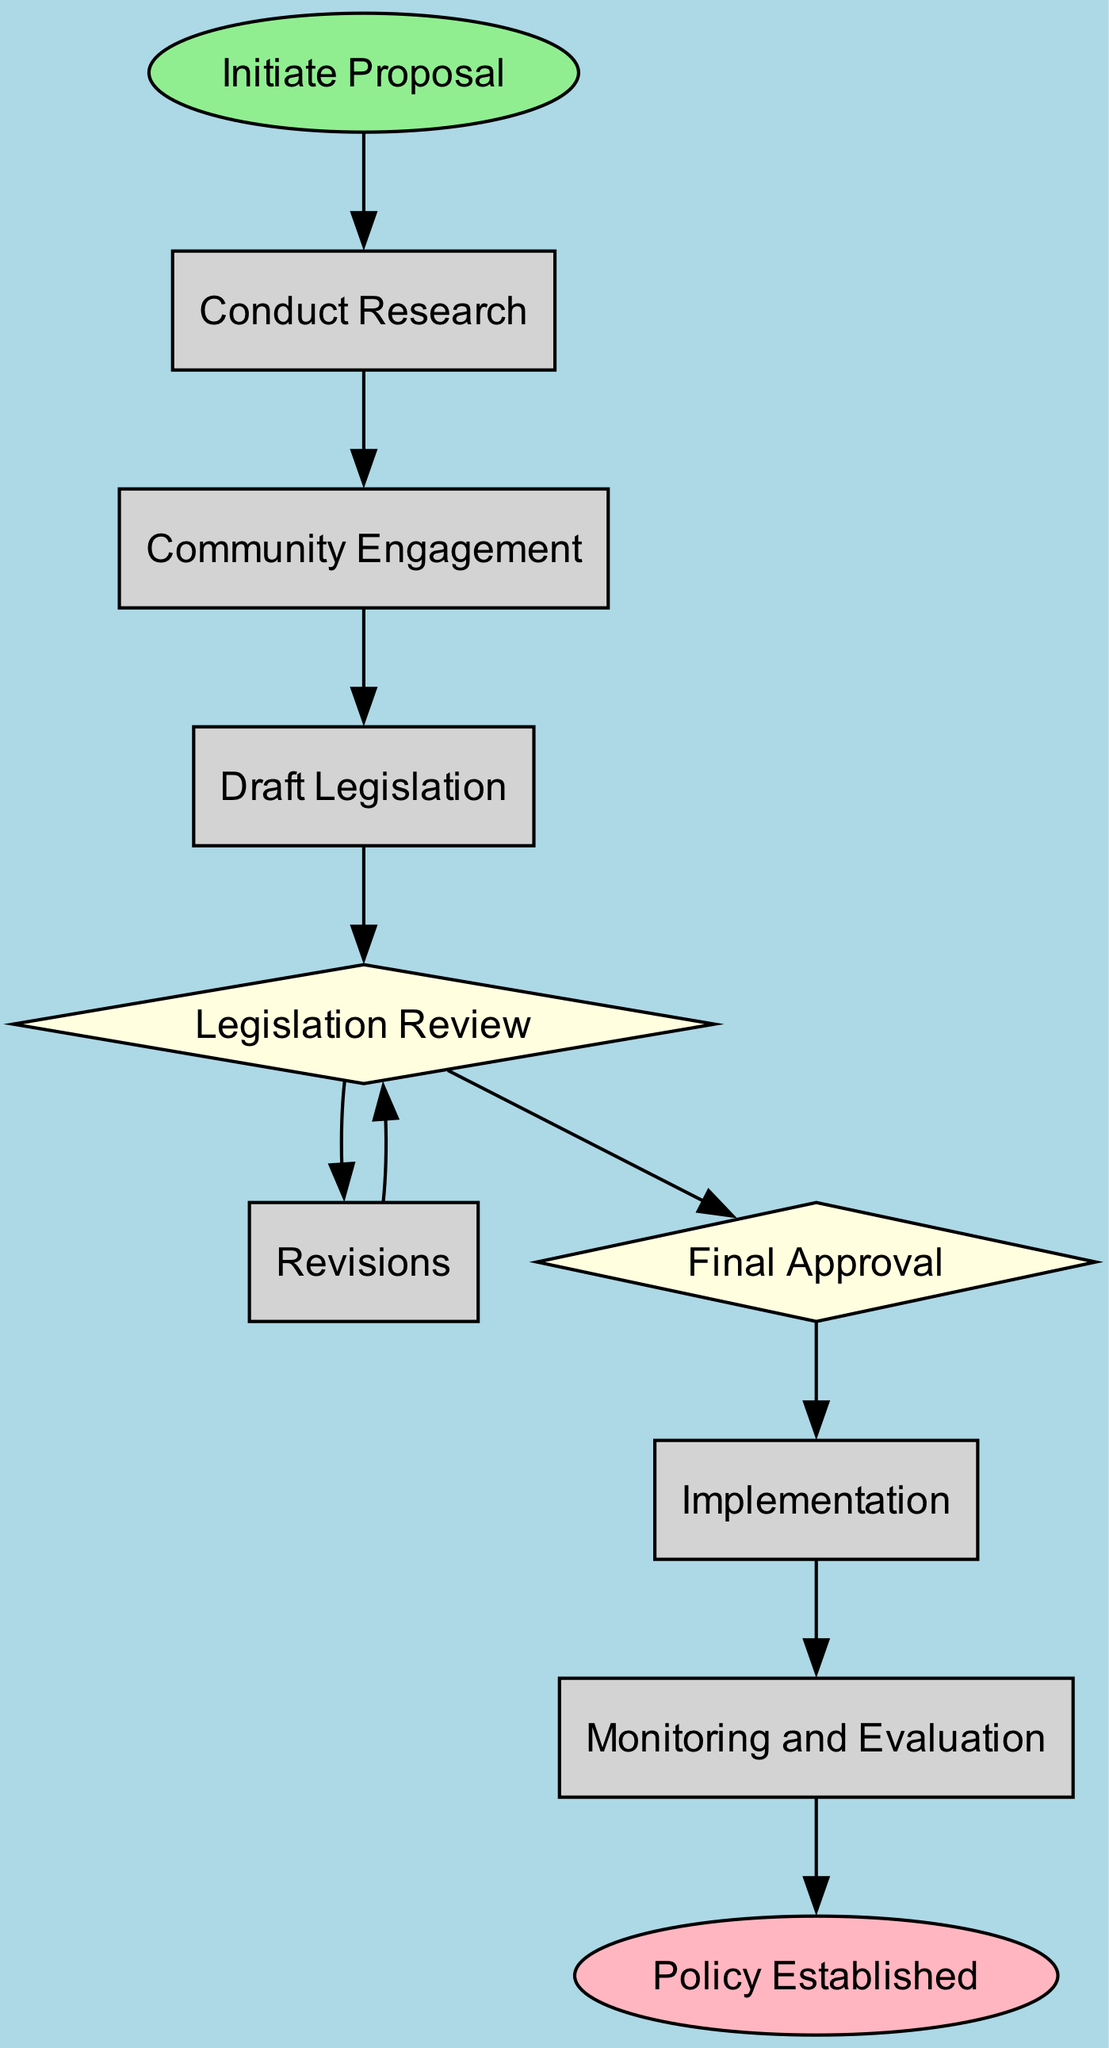What is the first step in the legislation process? The diagram clearly indicates that the first step is labeled "Initiate Proposal". This is the initial action that recognizes the importance of mangroves.
Answer: Initiate Proposal How many processes are included in the diagram? By counting the nodes labeled as "process," we find that there are five processes: Conduct Research, Community Engagement, Draft Legislation, Revisions, and Implementation.
Answer: Five What node follows "Legislation Review"? According to the flow of the diagram, after "Legislation Review", the next node is "Revisions", indicating that feedback is incorporated into the legislation before further approval.
Answer: Revisions Which step is required after "Community Engagement"? The diagram shows that "Community Engagement" is directly followed by "Draft Legislation", meaning that after engaging with the community, the next step is to work on drafting the new legislation.
Answer: Draft Legislation What type of node is "Final Approval"? In the diagram, "Final Approval" is a decision node, as it is represented in a diamond shape, indicating that this step involves making a choice about the approval of the legislation.
Answer: Decision What does the "Monitoring and Evaluation" step entail? The diagram describes "Monitoring and Evaluation" as a process where the effectiveness of the implemented policy is assessed over time, ensuring continuous improvement.
Answer: Continuous improvement How many decision points are there in the diagram? By analyzing the diagram, we identify two decision points: "Legislation Review" and "Final Approval", which are crucial steps that require evaluation before proceeding.
Answer: Two What is the final outcome of the process? The last node in the diagram, labeled "Policy Established", signifies that the entire mangrove protection policy is fully established and operational.
Answer: Policy Established What relationship exists between "Review" and "Revisions"? The diagram indicates a feedback loop between "Review" and "Revisions", where revisions are made based on the review before moving forward to the approval stage, showcasing an iterative process.
Answer: Feedback loop 